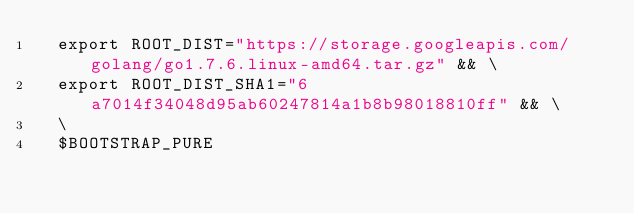Convert code to text. <code><loc_0><loc_0><loc_500><loc_500><_Dockerfile_>  export ROOT_DIST="https://storage.googleapis.com/golang/go1.7.6.linux-amd64.tar.gz" && \
  export ROOT_DIST_SHA1="6a7014f34048d95ab60247814a1b8b98018810ff" && \
  \
  $BOOTSTRAP_PURE
</code> 